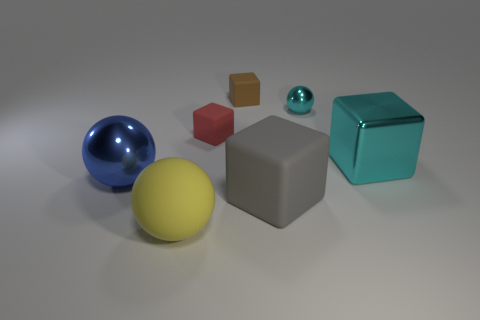Is the shiny block the same color as the small ball?
Make the answer very short. Yes. There is a small red object that is the same material as the brown cube; what shape is it?
Your answer should be compact. Cube. What number of rubber objects are the same color as the large rubber cube?
Make the answer very short. 0. How many objects are big gray balls or red matte cubes?
Offer a terse response. 1. What is the material of the large ball that is to the left of the sphere in front of the gray block?
Keep it short and to the point. Metal. Are there any big brown things made of the same material as the yellow ball?
Give a very brief answer. No. What shape is the large rubber object to the left of the small rubber cube in front of the rubber block behind the small cyan metallic ball?
Offer a terse response. Sphere. What is the material of the tiny red thing?
Provide a short and direct response. Rubber. There is a big thing that is the same material as the big cyan block; what color is it?
Your answer should be compact. Blue. Is there a small object that is in front of the sphere that is to the right of the red matte cube?
Make the answer very short. Yes. 